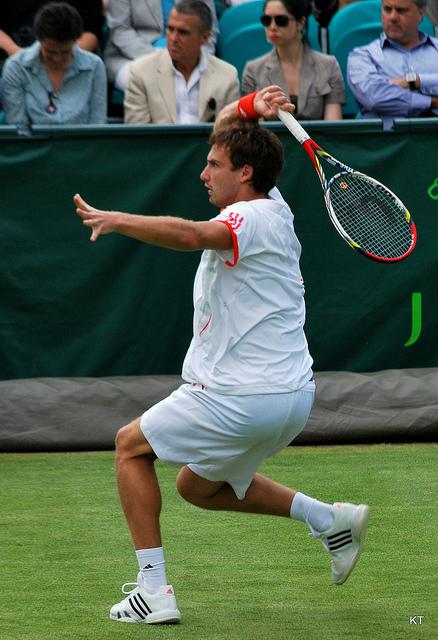What lime green letter is on the right of the banner?
Concise answer only. J. Does the player wear wristbands?
Write a very short answer. Yes. What sport is this person playing?
Be succinct. Tennis. 